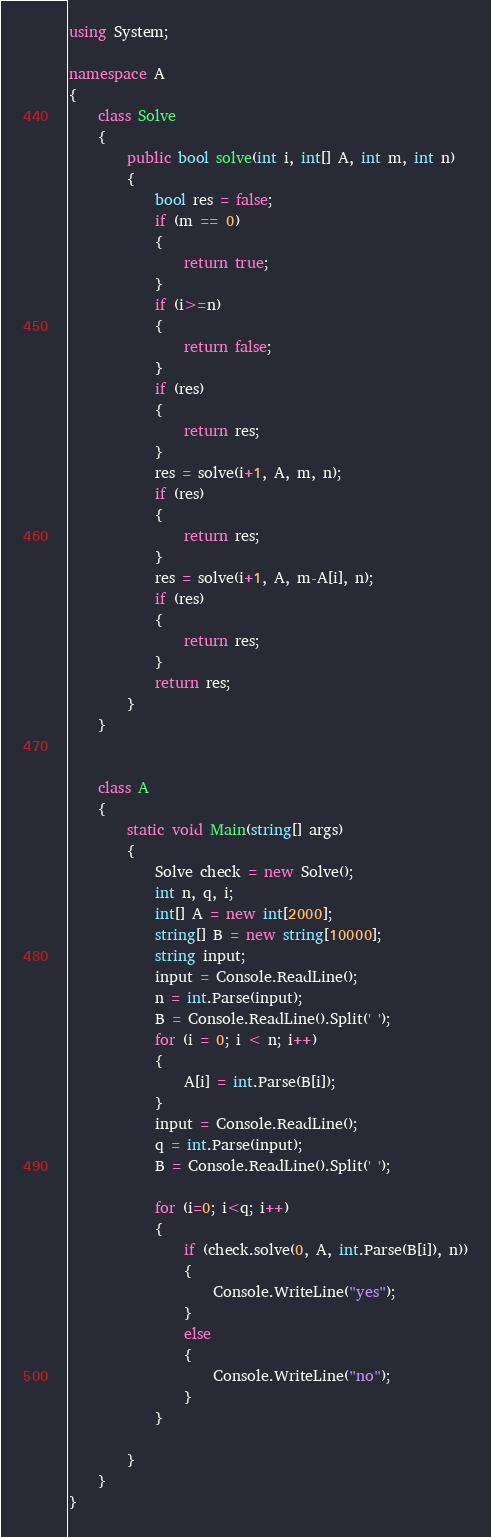Convert code to text. <code><loc_0><loc_0><loc_500><loc_500><_C#_>using System;

namespace A
{
    class Solve
    {
        public bool solve(int i, int[] A, int m, int n)
        {
            bool res = false;
            if (m == 0)
            {
                return true;
            }
            if (i>=n)
            {
                return false;
            }
            if (res)
            {
                return res;
            }
            res = solve(i+1, A, m, n);
            if (res)
            {
                return res;
            }
            res = solve(i+1, A, m-A[i], n);
            if (res)
            {
                return res;
            }
            return res;
        }
    }
    

    class A
    {
        static void Main(string[] args)
        {
            Solve check = new Solve();
            int n, q, i;
            int[] A = new int[2000];
            string[] B = new string[10000];
            string input;
            input = Console.ReadLine();
            n = int.Parse(input);
            B = Console.ReadLine().Split(' ');
            for (i = 0; i < n; i++)
            {
                A[i] = int.Parse(B[i]);
            }
            input = Console.ReadLine();
            q = int.Parse(input);
            B = Console.ReadLine().Split(' ');

            for (i=0; i<q; i++)
            {
                if (check.solve(0, A, int.Parse(B[i]), n))
                {
                    Console.WriteLine("yes");
                }
                else
                {
                    Console.WriteLine("no");
                }
            }

        }
    }
}

</code> 